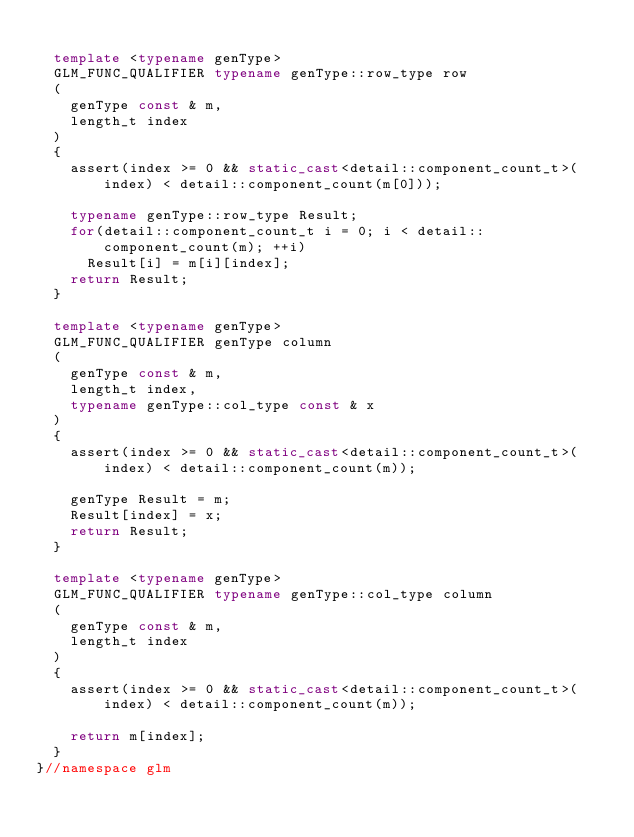Convert code to text. <code><loc_0><loc_0><loc_500><loc_500><_C++_>
	template <typename genType>
	GLM_FUNC_QUALIFIER typename genType::row_type row
	(
		genType const & m,
		length_t index
	)
	{
		assert(index >= 0 && static_cast<detail::component_count_t>(index) < detail::component_count(m[0]));

		typename genType::row_type Result;
		for(detail::component_count_t i = 0; i < detail::component_count(m); ++i)
			Result[i] = m[i][index];
		return Result;
	}

	template <typename genType>
	GLM_FUNC_QUALIFIER genType column
	(
		genType const & m,
		length_t index,
		typename genType::col_type const & x
	)
	{
		assert(index >= 0 && static_cast<detail::component_count_t>(index) < detail::component_count(m));

		genType Result = m;
		Result[index] = x;
		return Result;
	}

	template <typename genType>
	GLM_FUNC_QUALIFIER typename genType::col_type column
	(
		genType const & m,
		length_t index
	)
	{
		assert(index >= 0 && static_cast<detail::component_count_t>(index) < detail::component_count(m));

		return m[index];
	}
}//namespace glm
</code> 